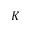<formula> <loc_0><loc_0><loc_500><loc_500>K</formula> 